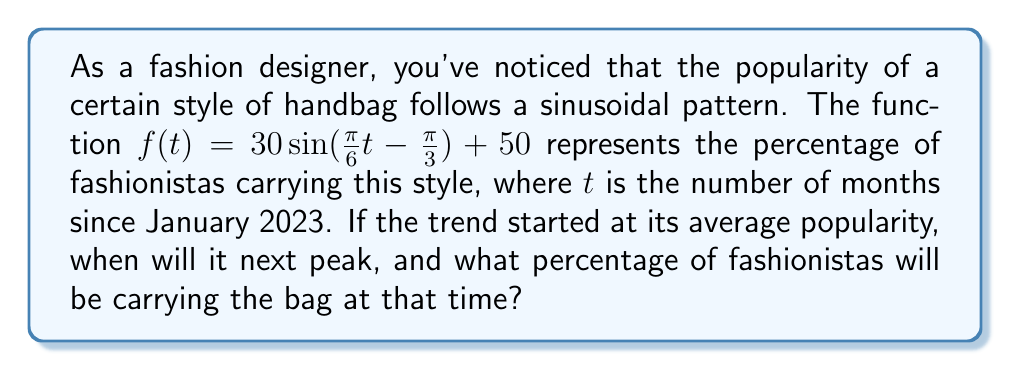Solve this math problem. Let's approach this step-by-step:

1) The general form of a sinusoidal function is:
   $f(t) = A \sin(B(t - C)) + D$
   where $A$ is the amplitude, $B$ is the frequency, $C$ is the phase shift, and $D$ is the vertical shift.

2) In our function $f(t) = 30 \sin(\frac{\pi}{6}t - \frac{\pi}{3}) + 50$:
   $A = 30$, $B = \frac{\pi}{6}$, $D = 50$

3) The period of the function is given by $\frac{2\pi}{B} = \frac{2\pi}{\frac{\pi}{6}} = 12$ months.

4) The trend started at its average popularity, which is represented by the vertical shift $D = 50$.

5) To find when it will peak, we need to find when the sine function equals 1:
   $\frac{\pi}{6}t - \frac{\pi}{3} = \frac{\pi}{2}$ (since $\sin(\frac{\pi}{2}) = 1$)

6) Solving for $t$:
   $\frac{\pi}{6}t = \frac{\pi}{2} + \frac{\pi}{3} = \frac{5\pi}{6}$
   $t = 5$ months

7) So the first peak will occur 5 months after January 2023, which is June 2023.

8) To find the percentage at the peak, we calculate $f(5)$:
   $f(5) = 30 \sin(\frac{\pi}{6}(5) - \frac{\pi}{3}) + 50$
   $= 30 \sin(\frac{5\pi}{6} - \frac{\pi}{3}) + 50$
   $= 30 \sin(\frac{\pi}{2}) + 50$
   $= 30(1) + 50 = 80$

Therefore, the trend will peak in June 2023 with 80% of fashionistas carrying the bag.
Answer: June 2023; 80% 